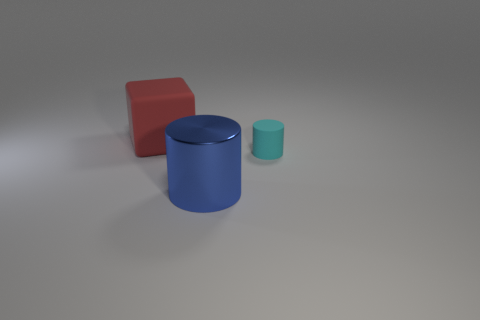How are the shadows oriented with respect to the objects? The shadows are extending diagonally towards the right side of the image, suggesting that the light source is coming from the left side, possibly overhead given the softness of the shadows. 